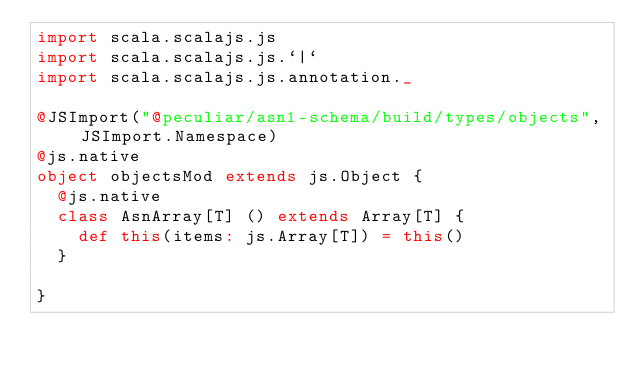Convert code to text. <code><loc_0><loc_0><loc_500><loc_500><_Scala_>import scala.scalajs.js
import scala.scalajs.js.`|`
import scala.scalajs.js.annotation._

@JSImport("@peculiar/asn1-schema/build/types/objects", JSImport.Namespace)
@js.native
object objectsMod extends js.Object {
  @js.native
  class AsnArray[T] () extends Array[T] {
    def this(items: js.Array[T]) = this()
  }
  
}

</code> 